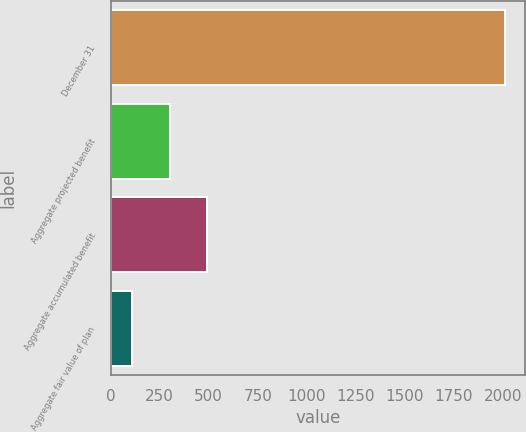Convert chart to OTSL. <chart><loc_0><loc_0><loc_500><loc_500><bar_chart><fcel>December 31<fcel>Aggregate projected benefit<fcel>Aggregate accumulated benefit<fcel>Aggregate fair value of plan<nl><fcel>2013<fcel>299.94<fcel>490.28<fcel>109.6<nl></chart> 